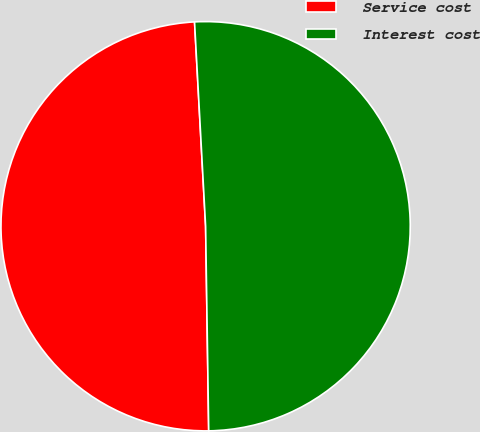Convert chart to OTSL. <chart><loc_0><loc_0><loc_500><loc_500><pie_chart><fcel>Service cost<fcel>Interest cost<nl><fcel>49.38%<fcel>50.62%<nl></chart> 